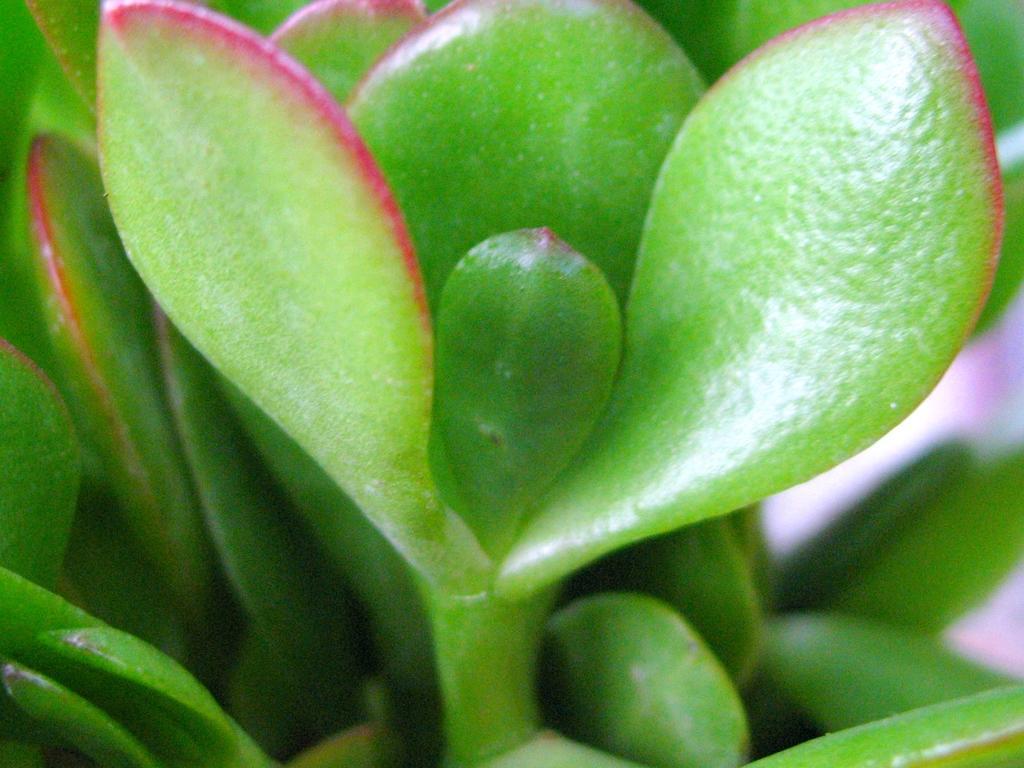In one or two sentences, can you explain what this image depicts? In this image we can see leaves and stem. 